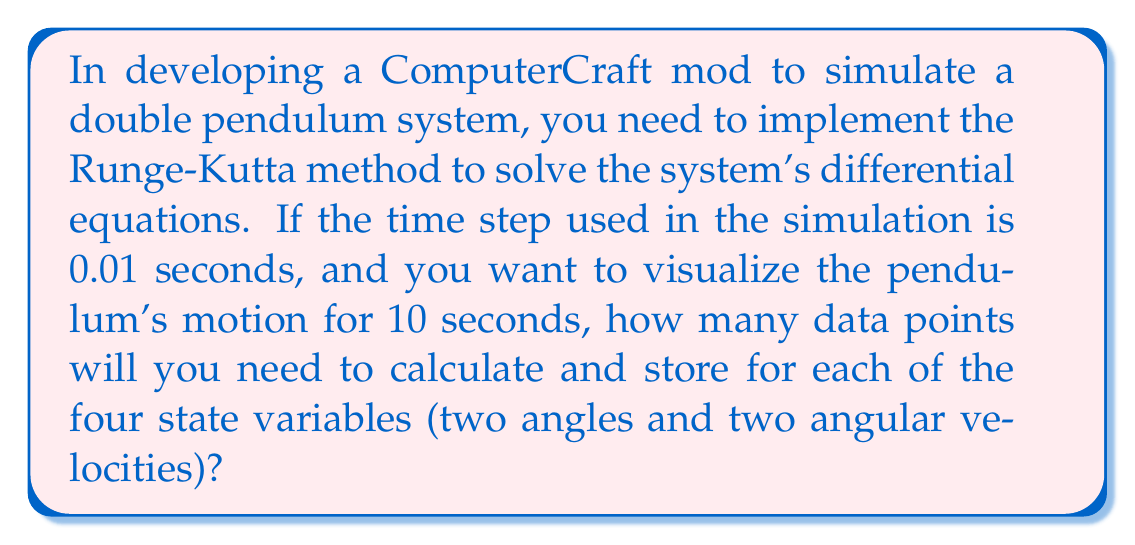Can you solve this math problem? To solve this problem, we need to follow these steps:

1. Understand the Runge-Kutta method requirements:
   The Runge-Kutta method (typically RK4) requires calculating intermediate values at each time step.

2. Identify the simulation parameters:
   - Time step: $\Delta t = 0.01$ seconds
   - Total simulation time: $T = 10$ seconds

3. Calculate the number of time steps:
   $$\text{Number of steps} = \frac{\text{Total time}}{\text{Time step}} = \frac{T}{\Delta t}$$
   $$\text{Number of steps} = \frac{10}{0.01} = 1000$$

4. Consider the state variables:
   For a double pendulum, we need to track:
   - Two angles (θ₁ and θ₂)
   - Two angular velocities (ω₁ and ω₂)

5. Calculate the total number of data points:
   $$\text{Total data points} = \text{Number of steps} \times \text{Number of state variables}$$
   $$\text{Total data points} = 1000 \times 4 = 4000$$

Therefore, you will need to calculate and store 4000 data points to fully represent the double pendulum's motion over the 10-second period.
Answer: 4000 data points 